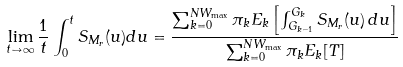<formula> <loc_0><loc_0><loc_500><loc_500>& \lim _ { t \to \infty } \frac { 1 } { t } \int _ { 0 } ^ { t } S _ { M _ { r } } ( u ) d u = \frac { \sum _ { k = 0 } ^ { N W _ { \max } } \pi _ { k } E _ { k } \left [ \int _ { G _ { k - 1 } } ^ { G _ { k } } S _ { M _ { r } } ( u ) \, d u \right ] } { \sum _ { k = 0 } ^ { N W _ { \max } } \pi _ { k } E _ { k } [ T ] } \\</formula> 